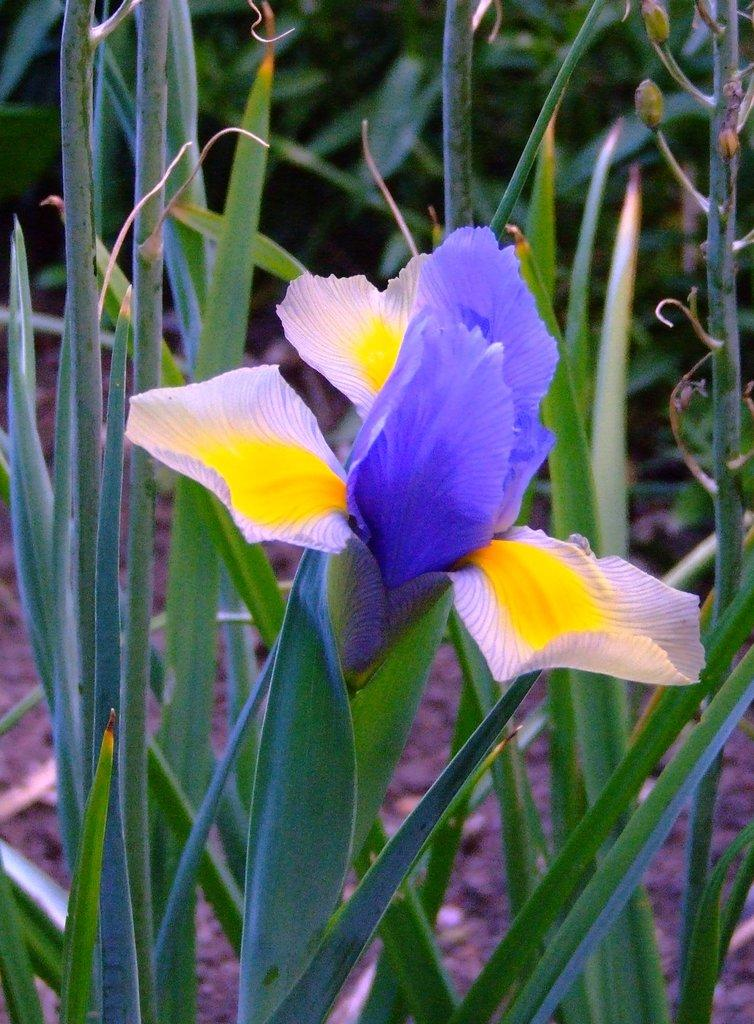What is the main subject of the image? The main subject of the image is a flower on a plant. What other features can be seen on the plant? The plant has leaves and buds. What can be seen in the background of the image? There are other plants in the background of the image. Where are the plants located? The plants are on the land. Can you tell me how many straws are in the image? There are no straws present in the image. What type of kitty can be seen playing with the frog in the image? There is no kitty or frog present in the image; it features a flower on a plant and other plants in the background. 